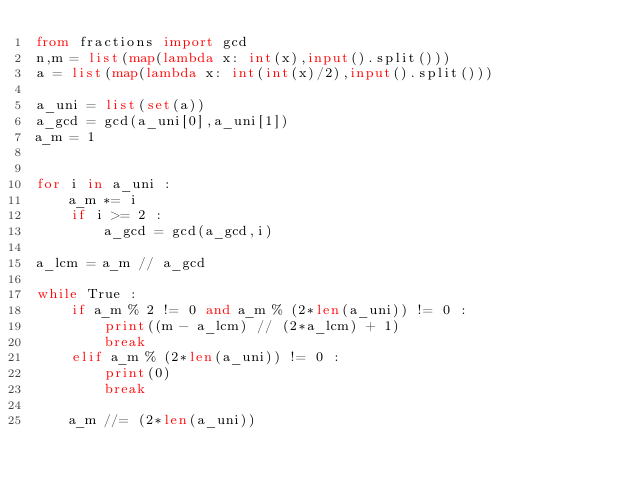Convert code to text. <code><loc_0><loc_0><loc_500><loc_500><_Python_>from fractions import gcd
n,m = list(map(lambda x: int(x),input().split()))
a = list(map(lambda x: int(int(x)/2),input().split()))

a_uni = list(set(a))
a_gcd = gcd(a_uni[0],a_uni[1])
a_m = 1


for i in a_uni :
    a_m *= i
    if i >= 2 :
        a_gcd = gcd(a_gcd,i)

a_lcm = a_m // a_gcd

while True :
    if a_m % 2 != 0 and a_m % (2*len(a_uni)) != 0 :
        print((m - a_lcm) // (2*a_lcm) + 1)
        break
    elif a_m % (2*len(a_uni)) != 0 :
        print(0)
        break

    a_m //= (2*len(a_uni))
</code> 